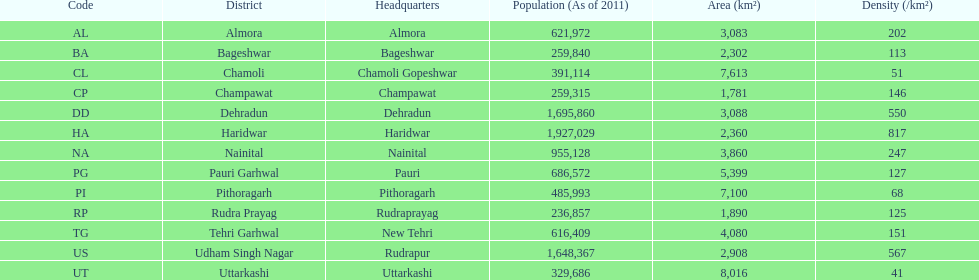Name a district where the density is merely 5 Chamoli. 